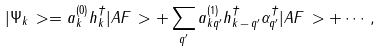<formula> <loc_0><loc_0><loc_500><loc_500>| \Psi _ { k } \, > = a ^ { ( 0 ) } _ { k } h ^ { \dagger } _ { k } | A F \, > + \sum _ { q ^ { \prime } } a ^ { ( 1 ) } _ { k q ^ { \prime } } h ^ { \dagger } _ { k \, - \, q ^ { \prime } } { \alpha } ^ { \dagger } _ { q ^ { \prime } } | A F \, > + \cdots ,</formula> 